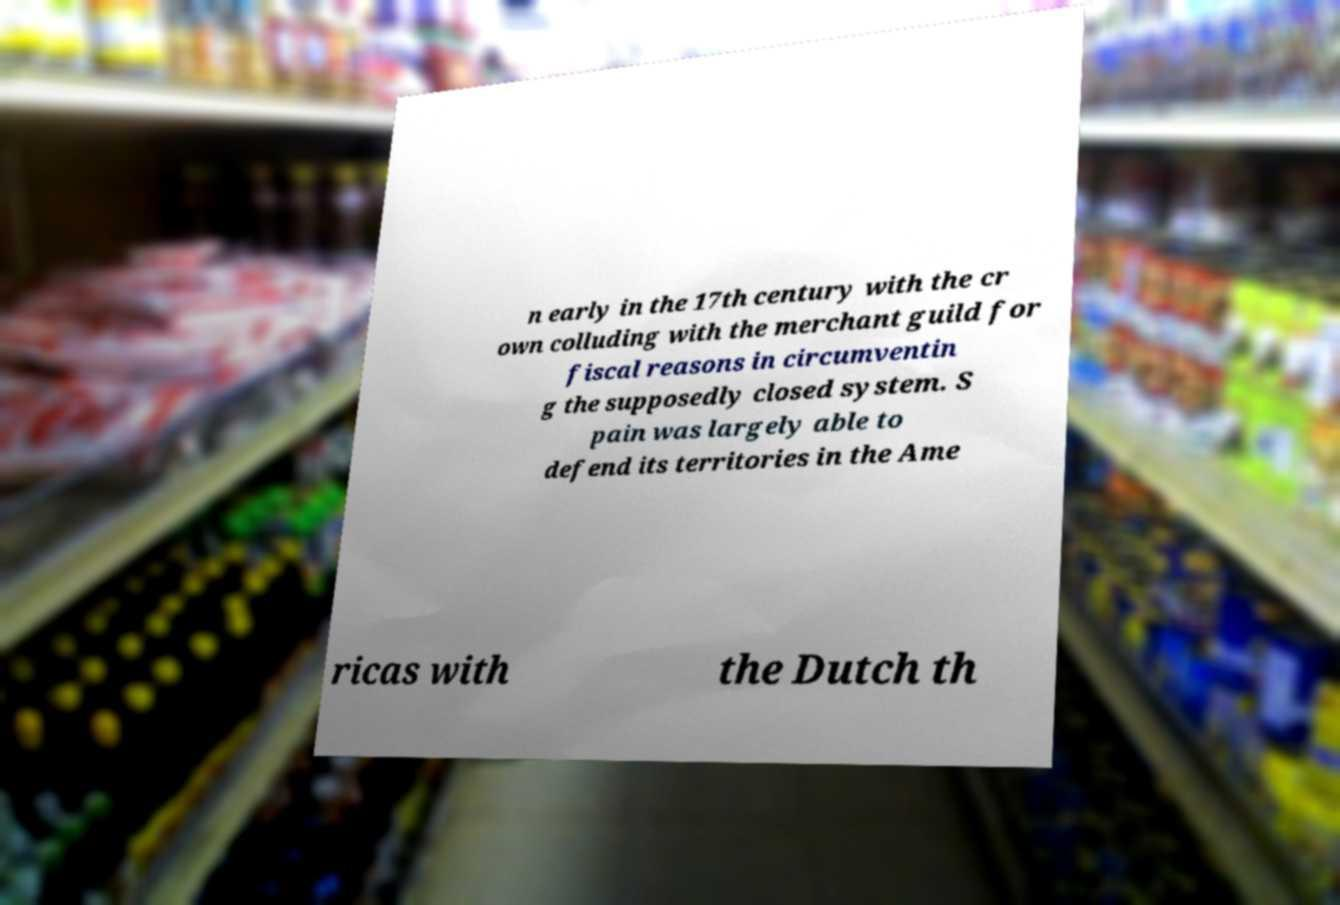Can you accurately transcribe the text from the provided image for me? n early in the 17th century with the cr own colluding with the merchant guild for fiscal reasons in circumventin g the supposedly closed system. S pain was largely able to defend its territories in the Ame ricas with the Dutch th 